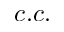Convert formula to latex. <formula><loc_0><loc_0><loc_500><loc_500>c . c .</formula> 